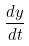Convert formula to latex. <formula><loc_0><loc_0><loc_500><loc_500>\frac { d y } { d t }</formula> 